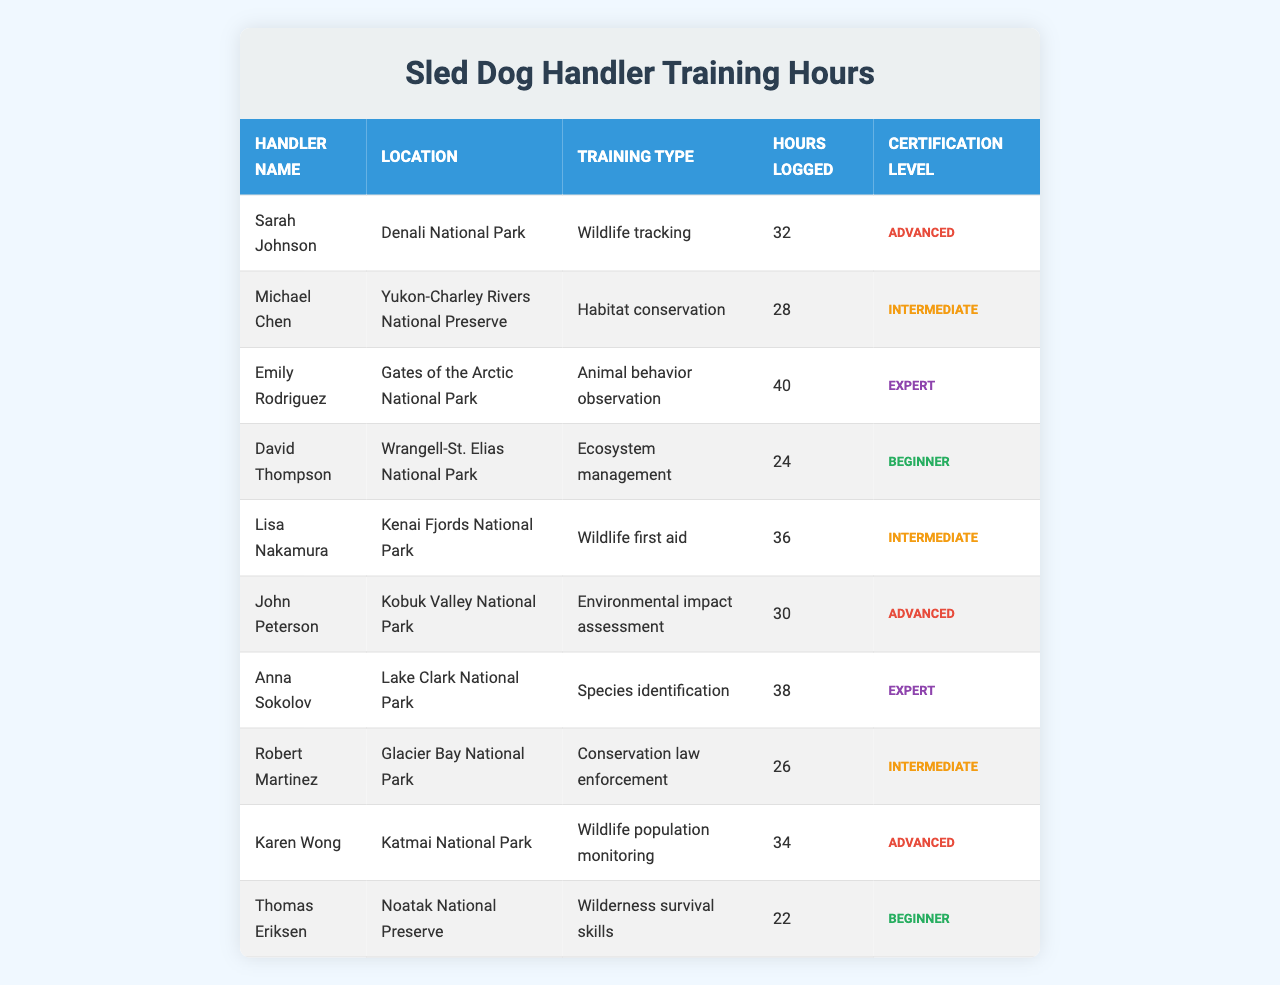What is the total number of training hours logged by all handlers? To find the total training hours, sum up all the hours logged: 32 + 28 + 40 + 24 + 36 + 30 + 38 + 26 + 34 + 22 = 340
Answer: 340 Which handler has logged the most training hours? Reviewing the table, Emily Rodriguez has logged the most hours with 40 hours.
Answer: Emily Rodriguez How many handlers have achieved an 'Expert' certification level? By examining the certification levels in the table, there are two handlers with 'Expert' certification: Emily Rodriguez and Anna Sokolov.
Answer: 2 What is the average number of training hours logged by handlers with 'Intermediate' certification? There are three handlers with 'Intermediate' certification: Michael Chen, Lisa Nakamura, and Robert Martinez. Their hours are 28, 36, and 26, respectively. The sum is 28 + 36 + 26 = 90, and there are 3 handlers, so the average is 90 / 3 = 30.
Answer: 30 Did any handler logged training hours below 25? When reviewing the hours logged, yes, Thomas Eriksen logged 22 hours, which is below 25.
Answer: Yes How many handlers are based in National Parks, and how many are in Preserves? Count the handlers listed under National Parks: 7 (Sarah Johnson, Emily Rodriguez, Lisa Nakamura, John Peterson, Anna Sokolov, Karen Wong, and David Thompson) and those listed under Preserves: 3 (Michael Chen, Robert Martinez, and Thomas Eriksen).
Answer: 7 in parks, 3 in preserves What is the certification level of the handler who logged the least hours? Thomas Eriksen logged the least hours with 22 hours, and his certification level is 'Beginner'.
Answer: Beginner Which training type has the highest logged hours, and who performed it? Looking at the table, 'Animal behavior observation' logged the highest with 40 hours, performed by Emily Rodriguez.
Answer: Animal behavior observation by Emily Rodriguez What is the difference between the hours logged by the highest and lowest certified handler? Emily Rodriguez, the highest certified handler, logged 40 hours, while Thomas Eriksen, the lowest certified handler, logged 22 hours. The difference is 40 - 22 = 18 hours.
Answer: 18 hours How many handlers specialize in 'Wildlife' related training types? Examining the training types: Wildlife tracking, Wildlife first aid, and Wildlife population monitoring are all wildlife-related, associated with 4 handlers (Sarah Johnson, Lisa Nakamura, and Karen Wong).
Answer: 4 handlers 